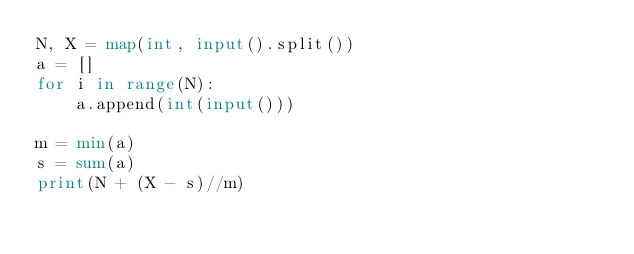<code> <loc_0><loc_0><loc_500><loc_500><_Python_>N, X = map(int, input().split())
a = []
for i in range(N):
    a.append(int(input()))
    
m = min(a)
s = sum(a)
print(N + (X - s)//m)</code> 